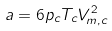Convert formula to latex. <formula><loc_0><loc_0><loc_500><loc_500>a = 6 p _ { c } T _ { c } V _ { m , c } ^ { 2 }</formula> 